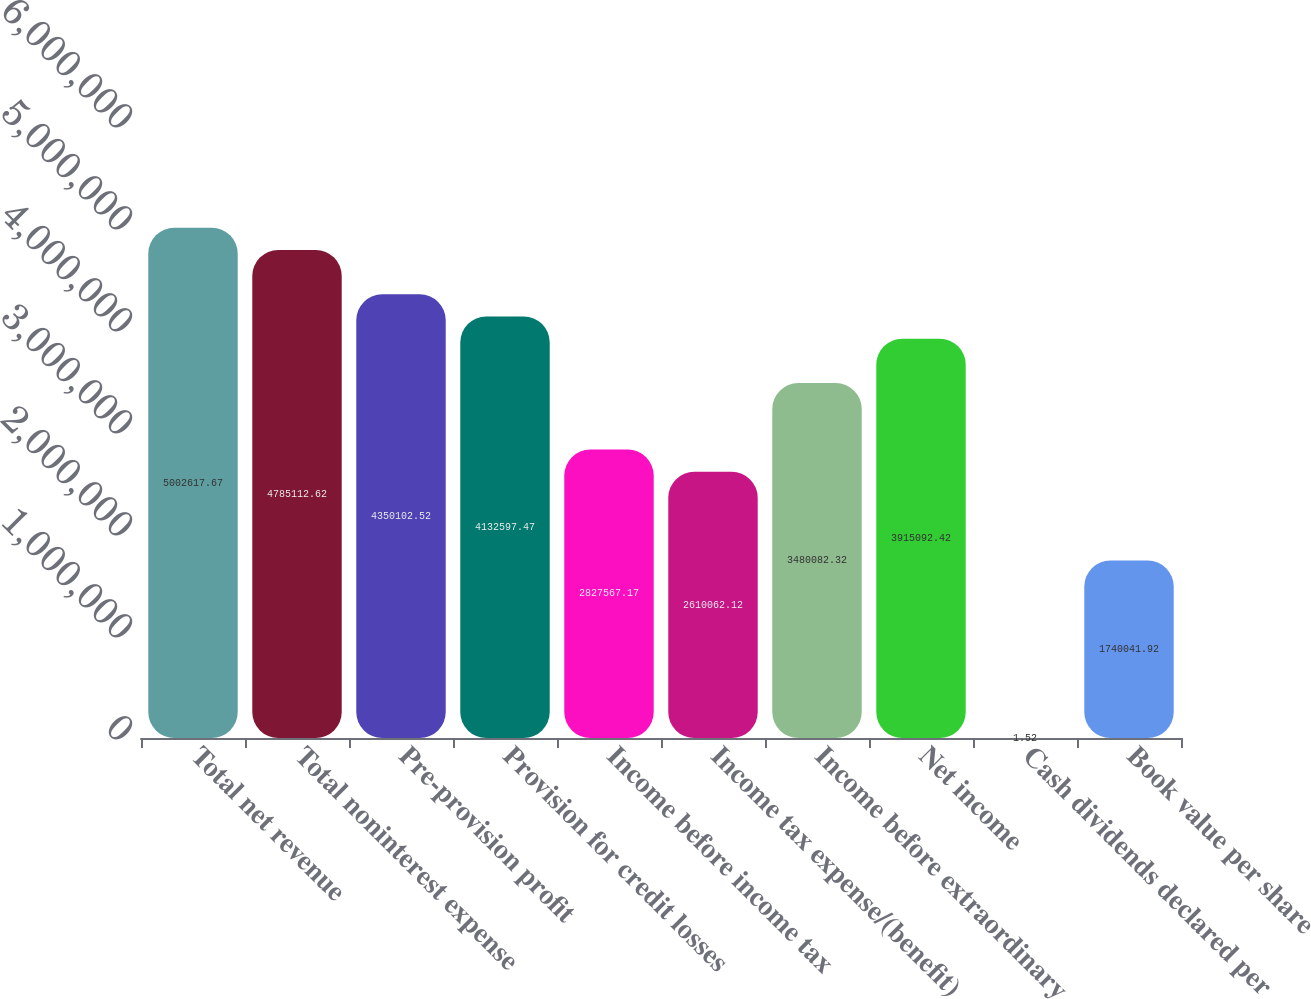Convert chart. <chart><loc_0><loc_0><loc_500><loc_500><bar_chart><fcel>Total net revenue<fcel>Total noninterest expense<fcel>Pre-provision profit<fcel>Provision for credit losses<fcel>Income before income tax<fcel>Income tax expense/(benefit)<fcel>Income before extraordinary<fcel>Net income<fcel>Cash dividends declared per<fcel>Book value per share<nl><fcel>5.00262e+06<fcel>4.78511e+06<fcel>4.3501e+06<fcel>4.1326e+06<fcel>2.82757e+06<fcel>2.61006e+06<fcel>3.48008e+06<fcel>3.91509e+06<fcel>1.52<fcel>1.74004e+06<nl></chart> 